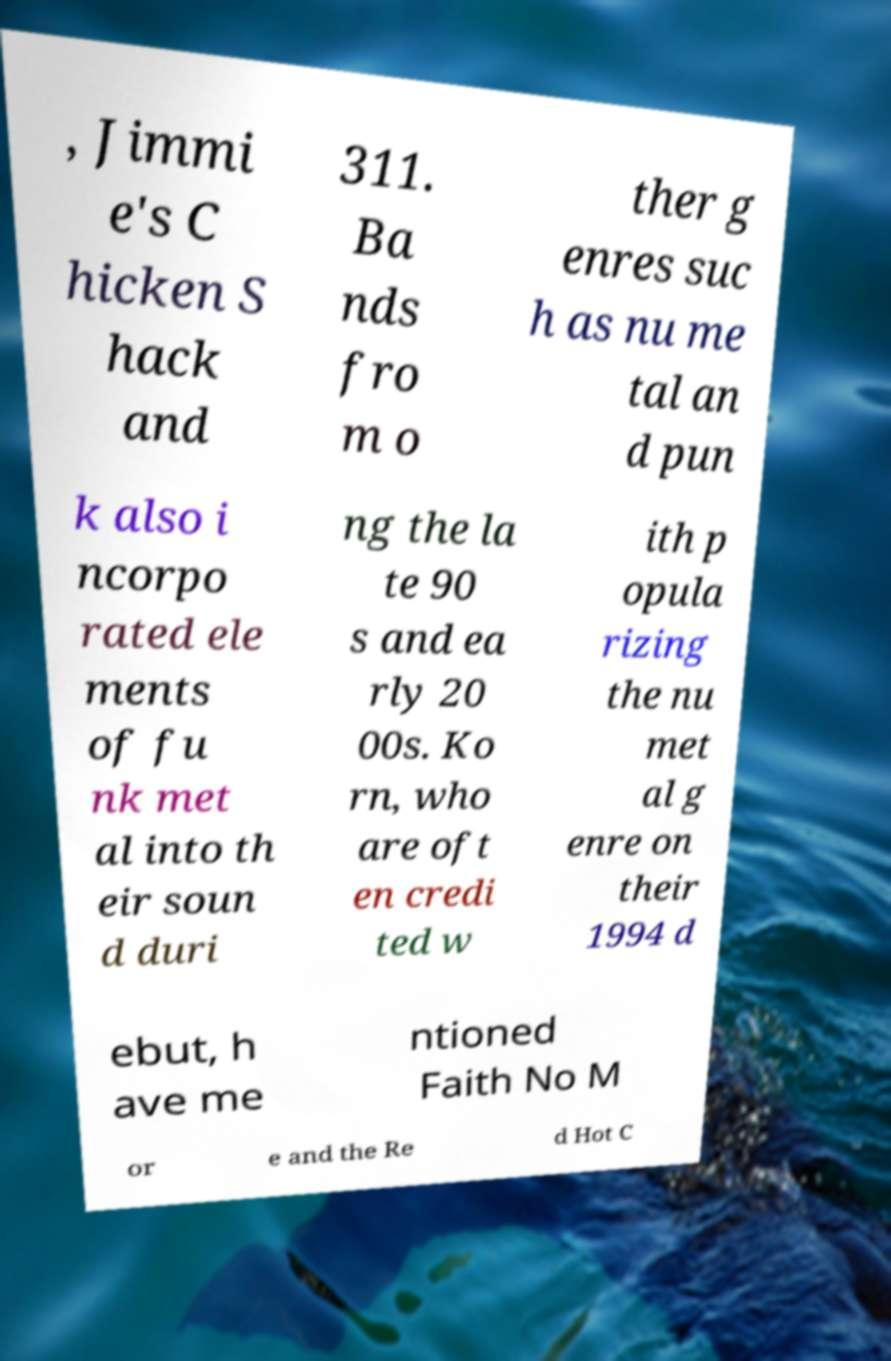There's text embedded in this image that I need extracted. Can you transcribe it verbatim? , Jimmi e's C hicken S hack and 311. Ba nds fro m o ther g enres suc h as nu me tal an d pun k also i ncorpo rated ele ments of fu nk met al into th eir soun d duri ng the la te 90 s and ea rly 20 00s. Ko rn, who are oft en credi ted w ith p opula rizing the nu met al g enre on their 1994 d ebut, h ave me ntioned Faith No M or e and the Re d Hot C 